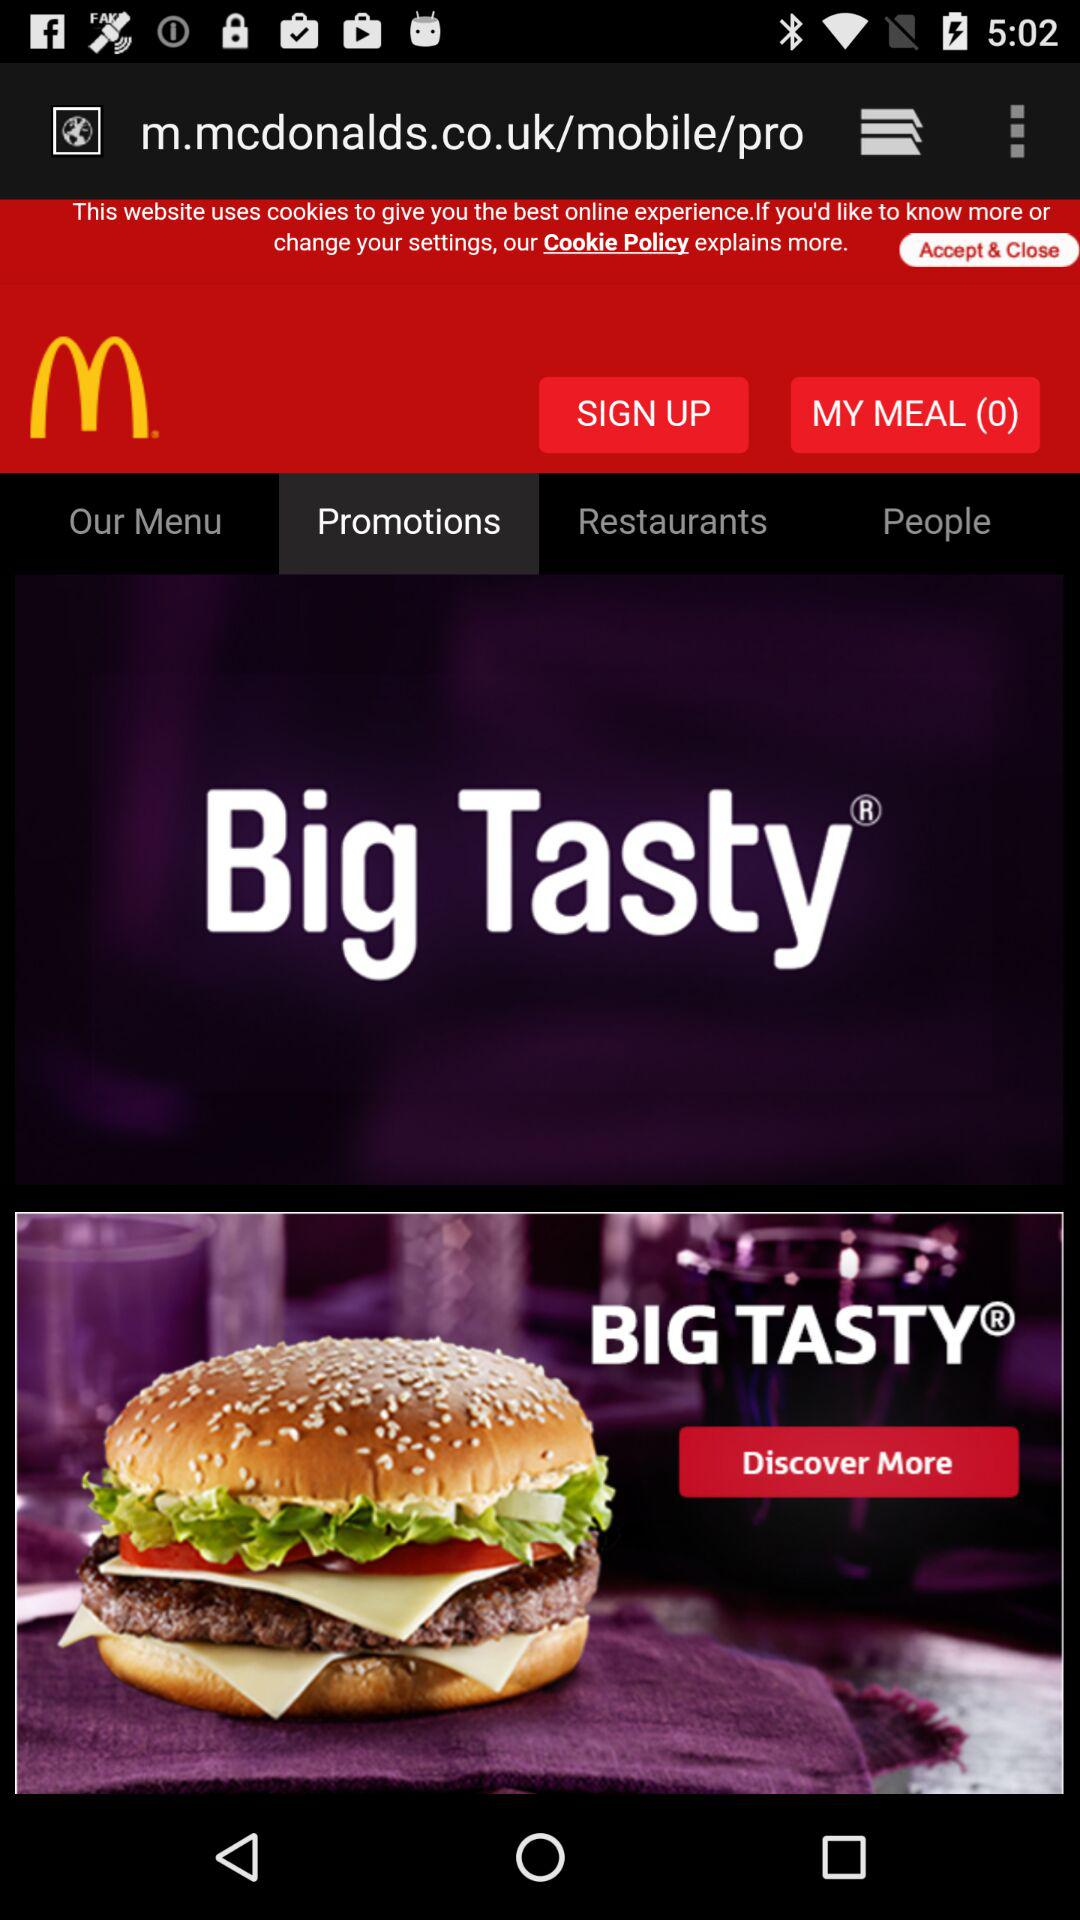What is the count of "MY MEAL"? The count of "MY MEAL" is 0. 